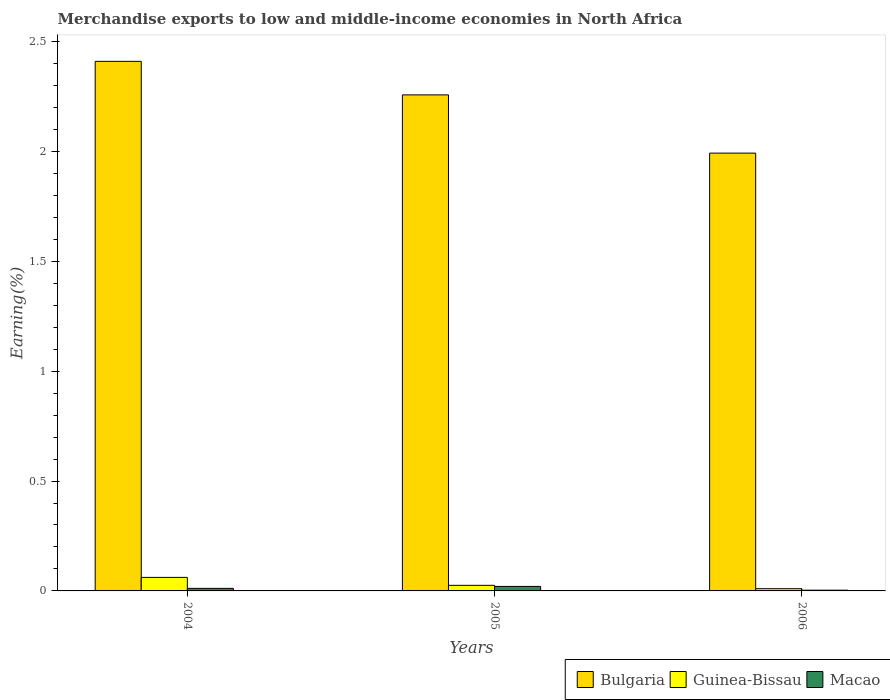How many bars are there on the 2nd tick from the right?
Provide a short and direct response. 3. What is the label of the 1st group of bars from the left?
Your response must be concise. 2004. In how many cases, is the number of bars for a given year not equal to the number of legend labels?
Your response must be concise. 0. What is the percentage of amount earned from merchandise exports in Guinea-Bissau in 2006?
Give a very brief answer. 0.01. Across all years, what is the maximum percentage of amount earned from merchandise exports in Guinea-Bissau?
Give a very brief answer. 0.06. Across all years, what is the minimum percentage of amount earned from merchandise exports in Guinea-Bissau?
Your response must be concise. 0.01. In which year was the percentage of amount earned from merchandise exports in Bulgaria maximum?
Provide a short and direct response. 2004. In which year was the percentage of amount earned from merchandise exports in Macao minimum?
Offer a very short reply. 2006. What is the total percentage of amount earned from merchandise exports in Bulgaria in the graph?
Ensure brevity in your answer.  6.66. What is the difference between the percentage of amount earned from merchandise exports in Bulgaria in 2004 and that in 2006?
Your answer should be very brief. 0.42. What is the difference between the percentage of amount earned from merchandise exports in Macao in 2005 and the percentage of amount earned from merchandise exports in Guinea-Bissau in 2004?
Keep it short and to the point. -0.04. What is the average percentage of amount earned from merchandise exports in Guinea-Bissau per year?
Your answer should be very brief. 0.03. In the year 2005, what is the difference between the percentage of amount earned from merchandise exports in Bulgaria and percentage of amount earned from merchandise exports in Guinea-Bissau?
Keep it short and to the point. 2.23. In how many years, is the percentage of amount earned from merchandise exports in Guinea-Bissau greater than 0.30000000000000004 %?
Your response must be concise. 0. What is the ratio of the percentage of amount earned from merchandise exports in Bulgaria in 2005 to that in 2006?
Your response must be concise. 1.13. Is the percentage of amount earned from merchandise exports in Macao in 2005 less than that in 2006?
Offer a terse response. No. Is the difference between the percentage of amount earned from merchandise exports in Bulgaria in 2004 and 2005 greater than the difference between the percentage of amount earned from merchandise exports in Guinea-Bissau in 2004 and 2005?
Your answer should be compact. Yes. What is the difference between the highest and the second highest percentage of amount earned from merchandise exports in Bulgaria?
Make the answer very short. 0.15. What is the difference between the highest and the lowest percentage of amount earned from merchandise exports in Guinea-Bissau?
Provide a succinct answer. 0.05. In how many years, is the percentage of amount earned from merchandise exports in Macao greater than the average percentage of amount earned from merchandise exports in Macao taken over all years?
Offer a terse response. 1. What does the 3rd bar from the left in 2006 represents?
Your answer should be very brief. Macao. What does the 2nd bar from the right in 2006 represents?
Your response must be concise. Guinea-Bissau. How many bars are there?
Give a very brief answer. 9. Are all the bars in the graph horizontal?
Keep it short and to the point. No. How many years are there in the graph?
Offer a terse response. 3. What is the difference between two consecutive major ticks on the Y-axis?
Give a very brief answer. 0.5. Does the graph contain any zero values?
Provide a short and direct response. No. Does the graph contain grids?
Give a very brief answer. No. Where does the legend appear in the graph?
Your answer should be compact. Bottom right. What is the title of the graph?
Your answer should be very brief. Merchandise exports to low and middle-income economies in North Africa. What is the label or title of the Y-axis?
Give a very brief answer. Earning(%). What is the Earning(%) in Bulgaria in 2004?
Your answer should be very brief. 2.41. What is the Earning(%) in Guinea-Bissau in 2004?
Your answer should be very brief. 0.06. What is the Earning(%) of Macao in 2004?
Keep it short and to the point. 0.01. What is the Earning(%) in Bulgaria in 2005?
Ensure brevity in your answer.  2.26. What is the Earning(%) in Guinea-Bissau in 2005?
Give a very brief answer. 0.03. What is the Earning(%) in Macao in 2005?
Make the answer very short. 0.02. What is the Earning(%) of Bulgaria in 2006?
Your answer should be compact. 1.99. What is the Earning(%) of Guinea-Bissau in 2006?
Your response must be concise. 0.01. What is the Earning(%) of Macao in 2006?
Provide a short and direct response. 0. Across all years, what is the maximum Earning(%) of Bulgaria?
Your response must be concise. 2.41. Across all years, what is the maximum Earning(%) of Guinea-Bissau?
Make the answer very short. 0.06. Across all years, what is the maximum Earning(%) of Macao?
Ensure brevity in your answer.  0.02. Across all years, what is the minimum Earning(%) of Bulgaria?
Make the answer very short. 1.99. Across all years, what is the minimum Earning(%) of Guinea-Bissau?
Keep it short and to the point. 0.01. Across all years, what is the minimum Earning(%) of Macao?
Your answer should be compact. 0. What is the total Earning(%) of Bulgaria in the graph?
Give a very brief answer. 6.66. What is the total Earning(%) in Guinea-Bissau in the graph?
Your answer should be very brief. 0.1. What is the total Earning(%) in Macao in the graph?
Offer a very short reply. 0.04. What is the difference between the Earning(%) of Bulgaria in 2004 and that in 2005?
Keep it short and to the point. 0.15. What is the difference between the Earning(%) of Guinea-Bissau in 2004 and that in 2005?
Make the answer very short. 0.04. What is the difference between the Earning(%) of Macao in 2004 and that in 2005?
Provide a short and direct response. -0.01. What is the difference between the Earning(%) in Bulgaria in 2004 and that in 2006?
Ensure brevity in your answer.  0.42. What is the difference between the Earning(%) in Guinea-Bissau in 2004 and that in 2006?
Offer a very short reply. 0.05. What is the difference between the Earning(%) of Macao in 2004 and that in 2006?
Ensure brevity in your answer.  0.01. What is the difference between the Earning(%) in Bulgaria in 2005 and that in 2006?
Provide a short and direct response. 0.27. What is the difference between the Earning(%) in Guinea-Bissau in 2005 and that in 2006?
Give a very brief answer. 0.02. What is the difference between the Earning(%) in Macao in 2005 and that in 2006?
Your answer should be compact. 0.02. What is the difference between the Earning(%) of Bulgaria in 2004 and the Earning(%) of Guinea-Bissau in 2005?
Provide a succinct answer. 2.38. What is the difference between the Earning(%) of Bulgaria in 2004 and the Earning(%) of Macao in 2005?
Your answer should be compact. 2.39. What is the difference between the Earning(%) of Guinea-Bissau in 2004 and the Earning(%) of Macao in 2005?
Offer a terse response. 0.04. What is the difference between the Earning(%) in Bulgaria in 2004 and the Earning(%) in Guinea-Bissau in 2006?
Provide a short and direct response. 2.4. What is the difference between the Earning(%) of Bulgaria in 2004 and the Earning(%) of Macao in 2006?
Offer a terse response. 2.41. What is the difference between the Earning(%) of Guinea-Bissau in 2004 and the Earning(%) of Macao in 2006?
Your response must be concise. 0.06. What is the difference between the Earning(%) of Bulgaria in 2005 and the Earning(%) of Guinea-Bissau in 2006?
Give a very brief answer. 2.25. What is the difference between the Earning(%) of Bulgaria in 2005 and the Earning(%) of Macao in 2006?
Give a very brief answer. 2.25. What is the difference between the Earning(%) of Guinea-Bissau in 2005 and the Earning(%) of Macao in 2006?
Provide a short and direct response. 0.02. What is the average Earning(%) in Bulgaria per year?
Your response must be concise. 2.22. What is the average Earning(%) of Guinea-Bissau per year?
Give a very brief answer. 0.03. What is the average Earning(%) of Macao per year?
Give a very brief answer. 0.01. In the year 2004, what is the difference between the Earning(%) of Bulgaria and Earning(%) of Guinea-Bissau?
Your answer should be very brief. 2.35. In the year 2004, what is the difference between the Earning(%) in Bulgaria and Earning(%) in Macao?
Your response must be concise. 2.4. In the year 2004, what is the difference between the Earning(%) in Guinea-Bissau and Earning(%) in Macao?
Keep it short and to the point. 0.05. In the year 2005, what is the difference between the Earning(%) in Bulgaria and Earning(%) in Guinea-Bissau?
Your answer should be compact. 2.23. In the year 2005, what is the difference between the Earning(%) in Bulgaria and Earning(%) in Macao?
Your response must be concise. 2.24. In the year 2005, what is the difference between the Earning(%) in Guinea-Bissau and Earning(%) in Macao?
Your response must be concise. 0. In the year 2006, what is the difference between the Earning(%) of Bulgaria and Earning(%) of Guinea-Bissau?
Make the answer very short. 1.98. In the year 2006, what is the difference between the Earning(%) of Bulgaria and Earning(%) of Macao?
Ensure brevity in your answer.  1.99. In the year 2006, what is the difference between the Earning(%) of Guinea-Bissau and Earning(%) of Macao?
Offer a very short reply. 0.01. What is the ratio of the Earning(%) in Bulgaria in 2004 to that in 2005?
Your response must be concise. 1.07. What is the ratio of the Earning(%) in Guinea-Bissau in 2004 to that in 2005?
Ensure brevity in your answer.  2.42. What is the ratio of the Earning(%) in Macao in 2004 to that in 2005?
Keep it short and to the point. 0.57. What is the ratio of the Earning(%) of Bulgaria in 2004 to that in 2006?
Offer a very short reply. 1.21. What is the ratio of the Earning(%) of Guinea-Bissau in 2004 to that in 2006?
Provide a succinct answer. 6.04. What is the ratio of the Earning(%) in Macao in 2004 to that in 2006?
Your answer should be compact. 3.47. What is the ratio of the Earning(%) of Bulgaria in 2005 to that in 2006?
Make the answer very short. 1.13. What is the ratio of the Earning(%) of Guinea-Bissau in 2005 to that in 2006?
Your answer should be very brief. 2.49. What is the ratio of the Earning(%) of Macao in 2005 to that in 2006?
Ensure brevity in your answer.  6.13. What is the difference between the highest and the second highest Earning(%) of Bulgaria?
Provide a succinct answer. 0.15. What is the difference between the highest and the second highest Earning(%) of Guinea-Bissau?
Ensure brevity in your answer.  0.04. What is the difference between the highest and the second highest Earning(%) in Macao?
Give a very brief answer. 0.01. What is the difference between the highest and the lowest Earning(%) in Bulgaria?
Offer a very short reply. 0.42. What is the difference between the highest and the lowest Earning(%) of Guinea-Bissau?
Ensure brevity in your answer.  0.05. What is the difference between the highest and the lowest Earning(%) of Macao?
Give a very brief answer. 0.02. 